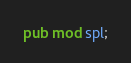Convert code to text. <code><loc_0><loc_0><loc_500><loc_500><_Rust_>pub mod spl;

</code> 